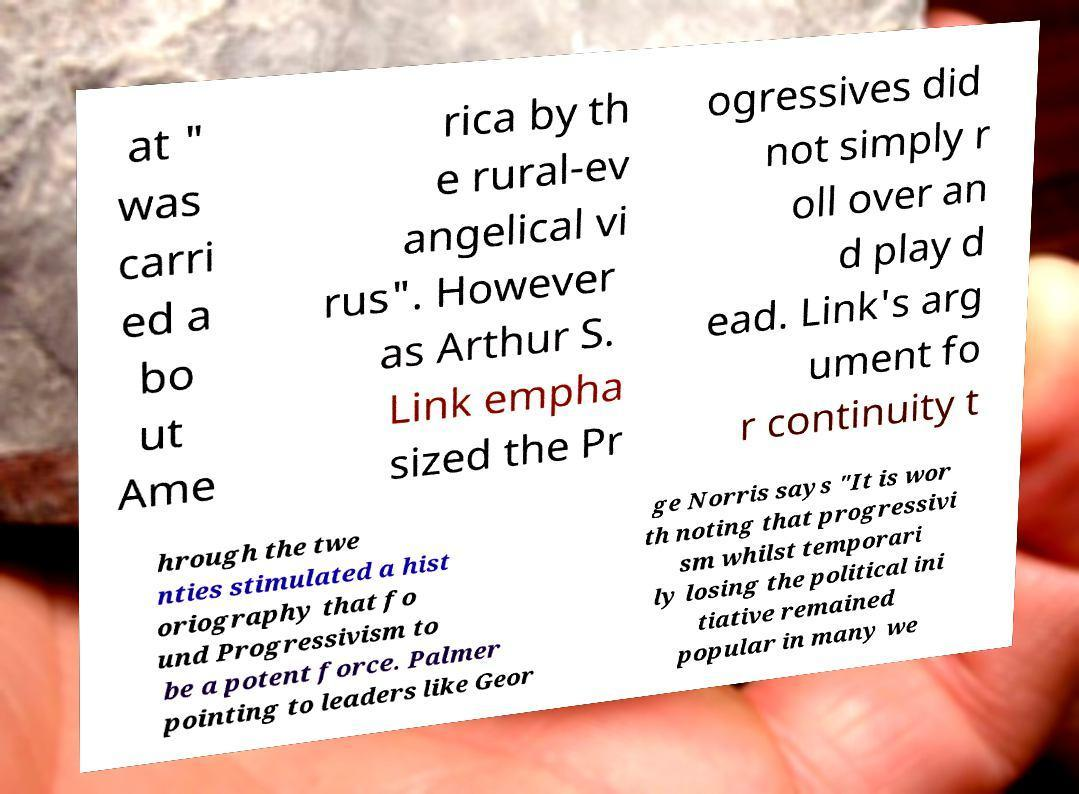Could you extract and type out the text from this image? at " was carri ed a bo ut Ame rica by th e rural-ev angelical vi rus". However as Arthur S. Link empha sized the Pr ogressives did not simply r oll over an d play d ead. Link's arg ument fo r continuity t hrough the twe nties stimulated a hist oriography that fo und Progressivism to be a potent force. Palmer pointing to leaders like Geor ge Norris says "It is wor th noting that progressivi sm whilst temporari ly losing the political ini tiative remained popular in many we 